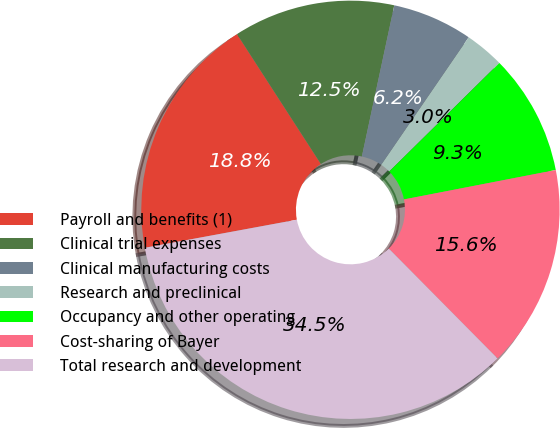Convert chart to OTSL. <chart><loc_0><loc_0><loc_500><loc_500><pie_chart><fcel>Payroll and benefits (1)<fcel>Clinical trial expenses<fcel>Clinical manufacturing costs<fcel>Research and preclinical<fcel>Occupancy and other operating<fcel>Cost-sharing of Bayer<fcel>Total research and development<nl><fcel>18.78%<fcel>12.49%<fcel>6.2%<fcel>3.05%<fcel>9.34%<fcel>15.63%<fcel>34.51%<nl></chart> 